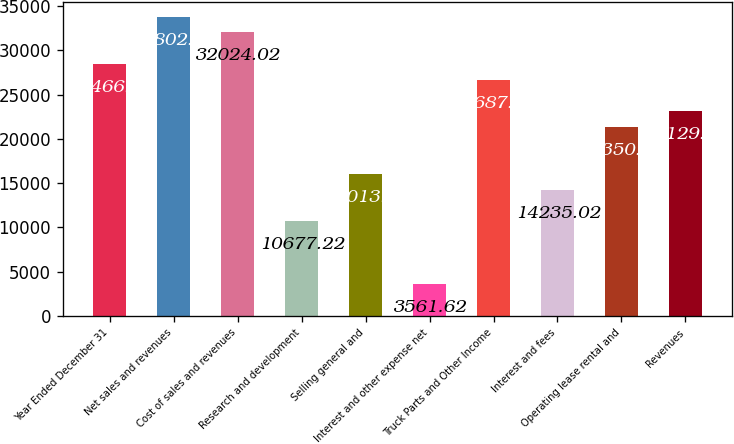<chart> <loc_0><loc_0><loc_500><loc_500><bar_chart><fcel>Year Ended December 31<fcel>Net sales and revenues<fcel>Cost of sales and revenues<fcel>Research and development<fcel>Selling general and<fcel>Interest and other expense net<fcel>Truck Parts and Other Income<fcel>Interest and fees<fcel>Operating lease rental and<fcel>Revenues<nl><fcel>28466.2<fcel>33802.9<fcel>32024<fcel>10677.2<fcel>16013.9<fcel>3561.62<fcel>26687.3<fcel>14235<fcel>21350.6<fcel>23129.5<nl></chart> 